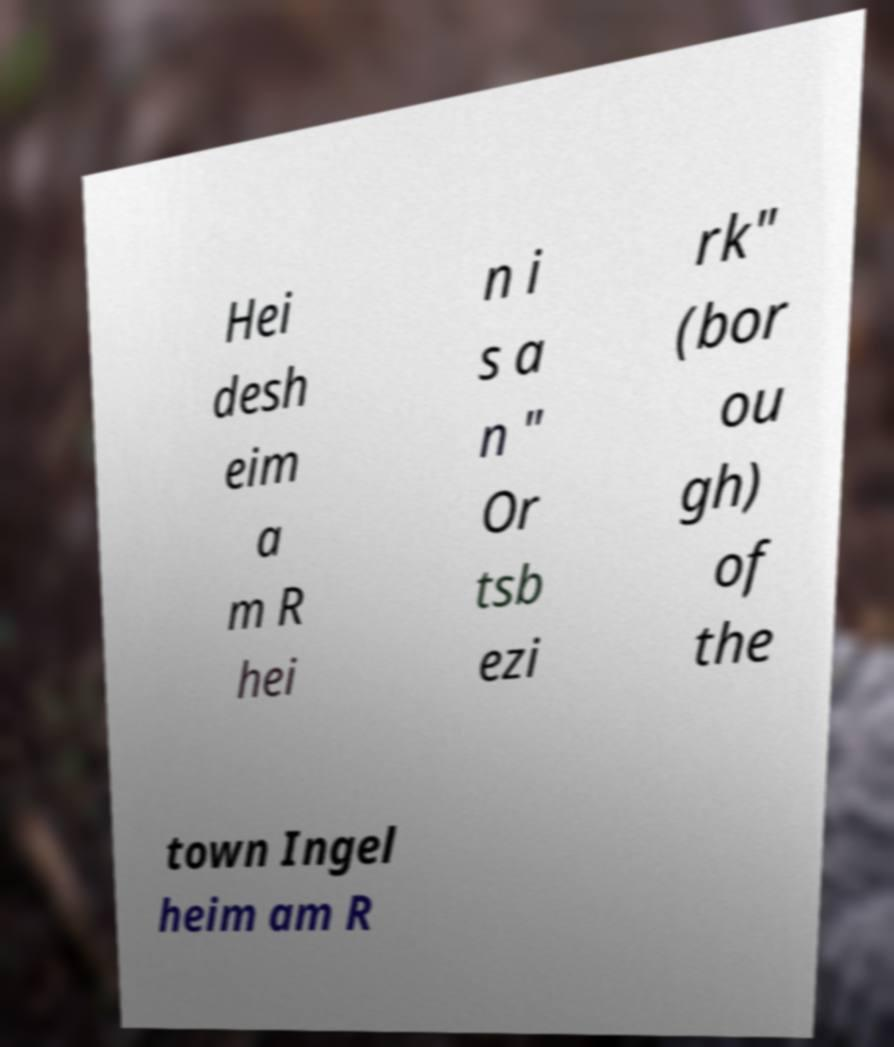Can you read and provide the text displayed in the image?This photo seems to have some interesting text. Can you extract and type it out for me? Hei desh eim a m R hei n i s a n " Or tsb ezi rk" (bor ou gh) of the town Ingel heim am R 